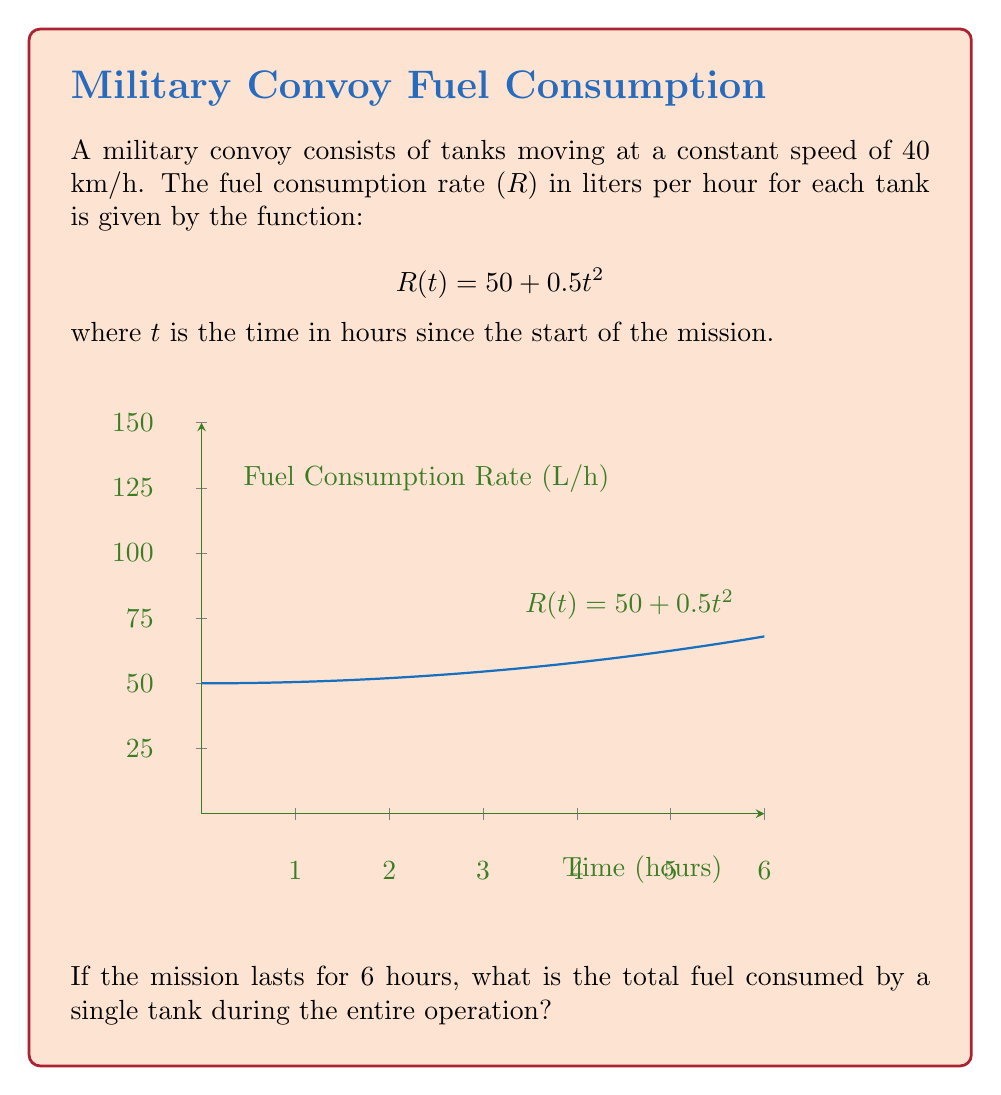Provide a solution to this math problem. To solve this problem, we need to integrate the fuel consumption rate function over the time period of the mission. Here's the step-by-step solution:

1) The fuel consumption rate is given by $R(t) = 50 + 0.5t^2$ liters per hour.

2) To find the total fuel consumed, we need to integrate this function from t = 0 to t = 6:

   $$\text{Total Fuel} = \int_0^6 R(t) dt = \int_0^6 (50 + 0.5t^2) dt$$

3) Let's integrate this function:
   
   $$\int_0^6 (50 + 0.5t^2) dt = [50t + \frac{1}{6}t^3]_0^6$$

4) Now, let's evaluate this definite integral:

   $$[50t + \frac{1}{6}t^3]_0^6 = (50 \cdot 6 + \frac{1}{6} \cdot 6^3) - (50 \cdot 0 + \frac{1}{6} \cdot 0^3)$$

5) Simplify:

   $$= (300 + 36) - 0 = 336$$

Therefore, a single tank consumes 336 liters of fuel during the 6-hour mission.
Answer: 336 liters 